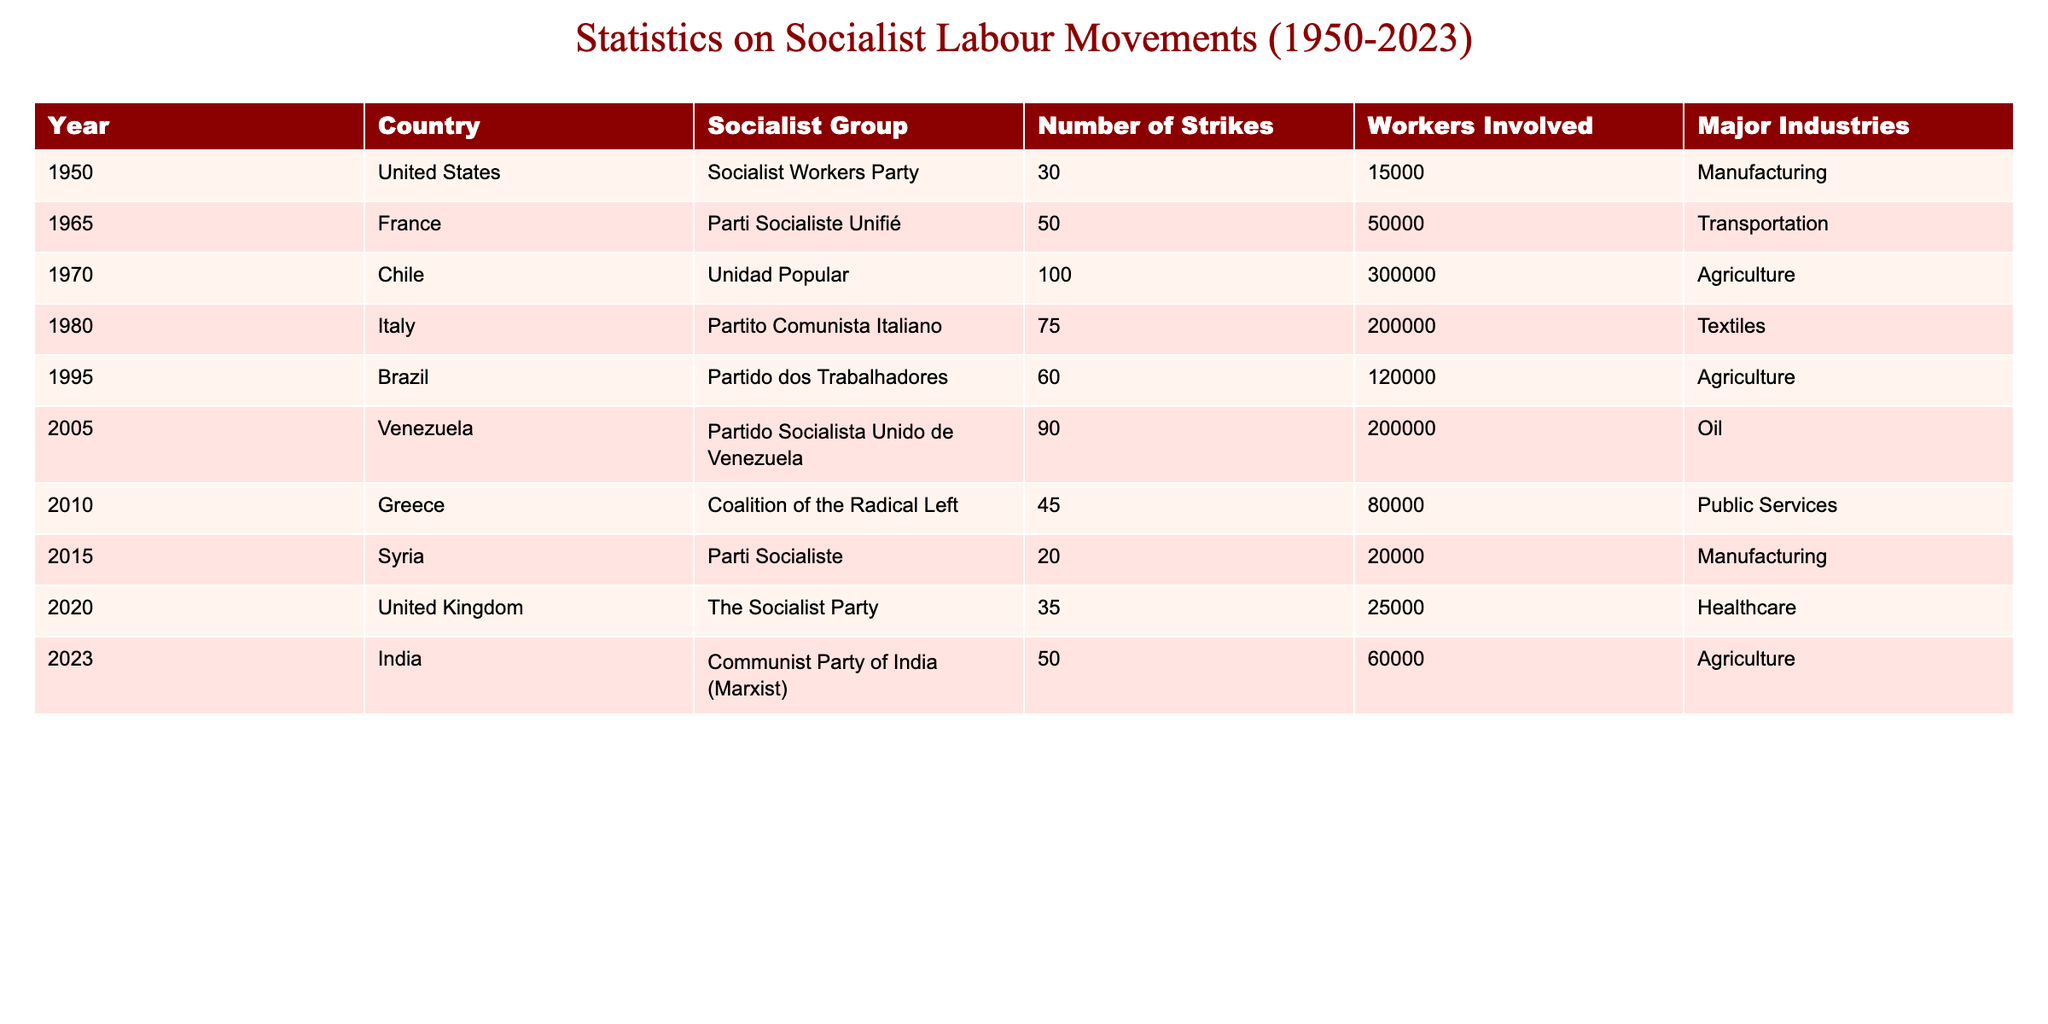What year saw the highest number of strikes? By scanning through the "Number of Strikes" column, I see that the year 1970 has the highest value at 100 strikes.
Answer: 1970 Which socialist group organized more than 80 strikes? Looking through the table, I find that the Unidad Popular in 1970 organized 100 strikes, and the Partido Socialista Unido de Venezuela in 2005 organized 90 strikes.
Answer: Unidad Popular, Partido Socialista Unido de Venezuela What is the total number of workers involved in strikes from 1950 to 2023? I sum the "Workers Involved" column by calculating: 15000 + 50000 + 300000 + 200000 + 120000 + 200000 + 80000 + 20000 + 25000 + 60000 = 1,116,000 workers.
Answer: 1,116,000 Did the Parti Socialiste in Syria organize more strikes than the Socialist Workers Party in the United States? The Parti Socialiste in Syria organized 20 strikes while the Socialist Workers Party organized 30 strikes. Since 30 is greater than 20, the answer is yes.
Answer: Yes What is the average number of strikes organized per year by the listed socialist groups? There are 10 data points (years). The total number of strikes is 30 + 50 + 100 + 75 + 60 + 90 + 45 + 20 + 35 + 50 = 510. To get the average, I divide 510 by 10, resulting in 51 strikes per year.
Answer: 51 Which major industry had the most strikes organized by socialist groups? I will compare the major industries listed: Manufacturing, Transportation, Agriculture, Textiles, Oil, and Public Services. Agriculture had 2 major instances (Chile in 1970 and Brazil in 1995, plus India in 2023), which exceeds any other individual industry, thus it is the industry with the most strikes.
Answer: Agriculture How many countries had socialist groups organizing strikes in the year 2005? In 2005, the only mentioned country is Venezuela with the Partido Socialista Unido de Venezuela organizing strikes. Hence there is only one country involved that year.
Answer: 1 Which year had the least number of workers involved in strikes? I examine the "Workers Involved" column and find that 20,000 workers were involved in the year 2015, which is the lowest number compared to other years.
Answer: 2015 What is the difference in the number of strikes between the highest and lowest recorded years? The highest recorded year is 1970 with 100 strikes while the lowest recorded year is 2015 with 20 strikes. The difference is calculated as 100 - 20 = 80 strikes.
Answer: 80 